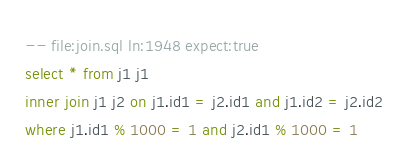<code> <loc_0><loc_0><loc_500><loc_500><_SQL_>-- file:join.sql ln:1948 expect:true
select * from j1 j1
inner join j1 j2 on j1.id1 = j2.id1 and j1.id2 = j2.id2
where j1.id1 % 1000 = 1 and j2.id1 % 1000 = 1
</code> 